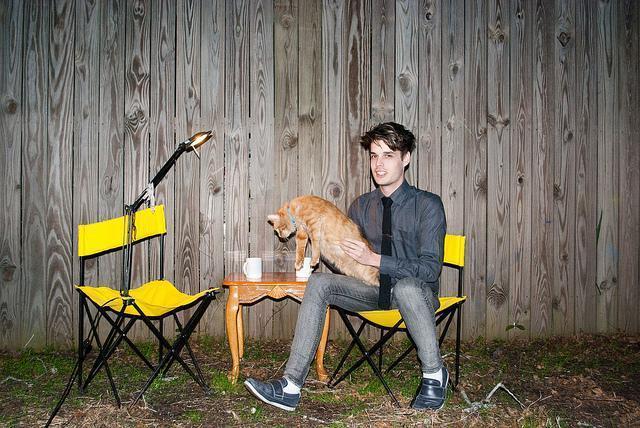How many chairs can you see?
Give a very brief answer. 2. 